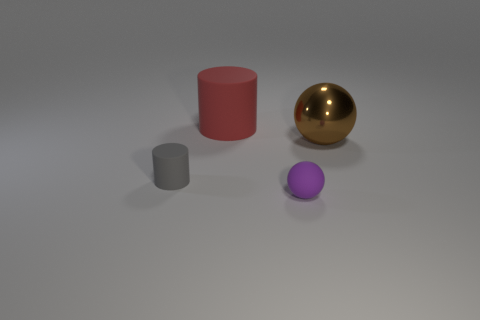Is there anything else that is made of the same material as the brown thing?
Provide a short and direct response. No. Is there a brown shiny object of the same size as the red thing?
Your answer should be compact. Yes. Does the tiny purple object have the same material as the cylinder in front of the large red thing?
Offer a very short reply. Yes. Are there more tiny things than small cylinders?
Keep it short and to the point. Yes. How many cubes are either large red things or small things?
Your answer should be compact. 0. What is the color of the metal ball?
Give a very brief answer. Brown. Do the cylinder on the right side of the small gray rubber thing and the object that is in front of the small rubber cylinder have the same size?
Make the answer very short. No. Are there fewer brown metallic things than small blue matte cylinders?
Offer a terse response. No. There is a large red object; what number of large metallic balls are right of it?
Ensure brevity in your answer.  1. What is the purple thing made of?
Make the answer very short. Rubber. 